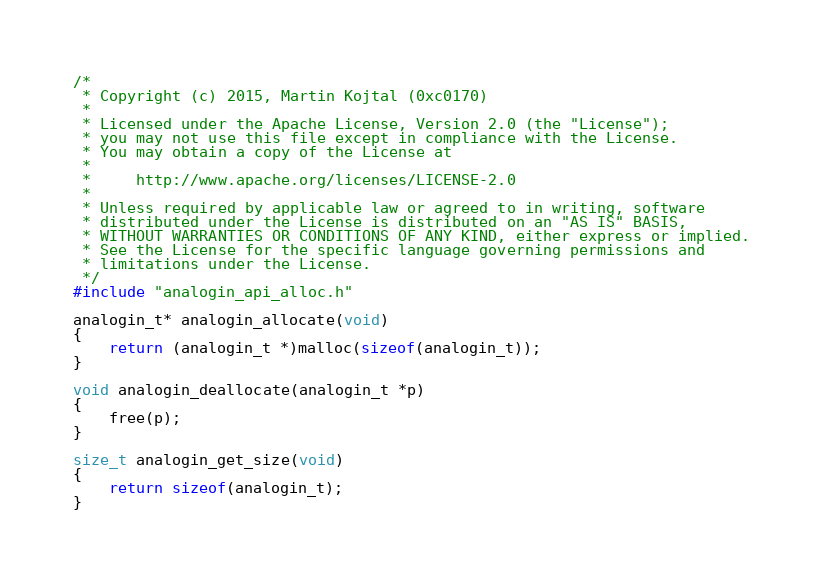<code> <loc_0><loc_0><loc_500><loc_500><_C_>/*
 * Copyright (c) 2015, Martin Kojtal (0xc0170)
 *
 * Licensed under the Apache License, Version 2.0 (the "License");
 * you may not use this file except in compliance with the License.
 * You may obtain a copy of the License at
 *
 *     http://www.apache.org/licenses/LICENSE-2.0
 *
 * Unless required by applicable law or agreed to in writing, software
 * distributed under the License is distributed on an "AS IS" BASIS,
 * WITHOUT WARRANTIES OR CONDITIONS OF ANY KIND, either express or implied.
 * See the License for the specific language governing permissions and
 * limitations under the License.
 */
#include "analogin_api_alloc.h"

analogin_t* analogin_allocate(void)
{
    return (analogin_t *)malloc(sizeof(analogin_t));
}

void analogin_deallocate(analogin_t *p)
{
    free(p);
}

size_t analogin_get_size(void)
{
    return sizeof(analogin_t);
}
</code> 